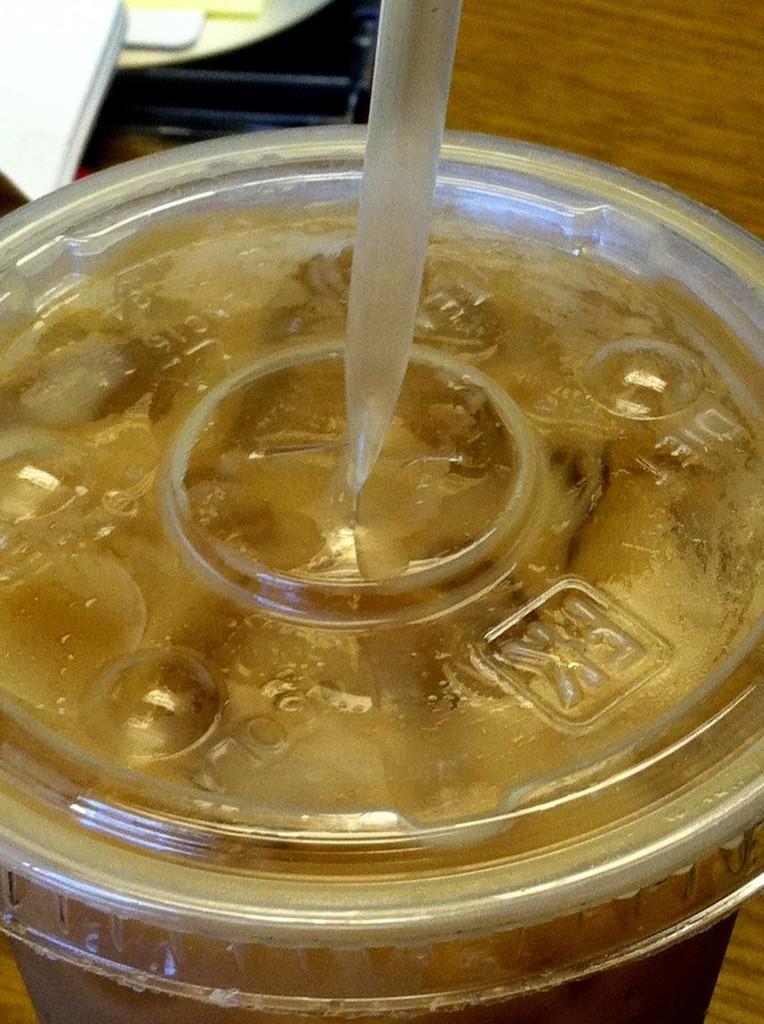Could you give a brief overview of what you see in this image? In this image I can see the glass. In the glass I can see some liquid in brown color and the glass is on the brown color surface and I can also see the straw. 